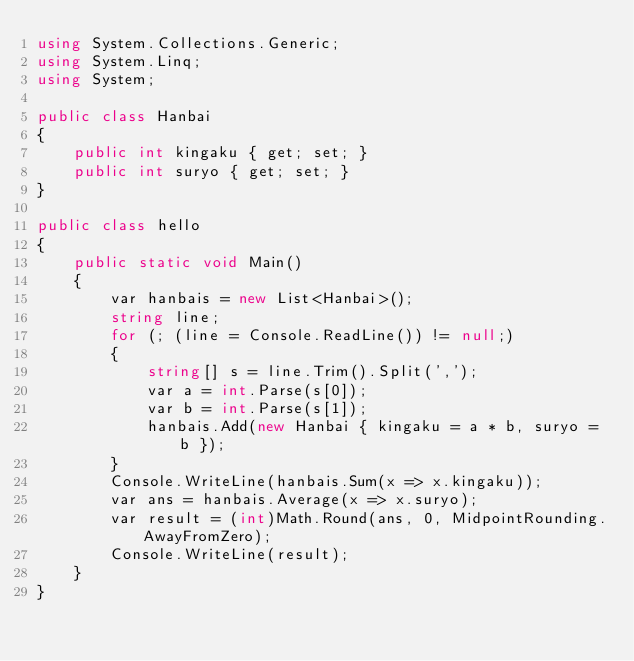<code> <loc_0><loc_0><loc_500><loc_500><_C#_>using System.Collections.Generic;
using System.Linq;
using System;

public class Hanbai
{
    public int kingaku { get; set; }
    public int suryo { get; set; }
}

public class hello
{
    public static void Main()
    {
        var hanbais = new List<Hanbai>();
        string line;
        for (; (line = Console.ReadLine()) != null;)
        {
            string[] s = line.Trim().Split(',');
            var a = int.Parse(s[0]);
            var b = int.Parse(s[1]);
            hanbais.Add(new Hanbai { kingaku = a * b, suryo = b });
        }
        Console.WriteLine(hanbais.Sum(x => x.kingaku));
        var ans = hanbais.Average(x => x.suryo);
        var result = (int)Math.Round(ans, 0, MidpointRounding.AwayFromZero);
        Console.WriteLine(result);
    }
}</code> 